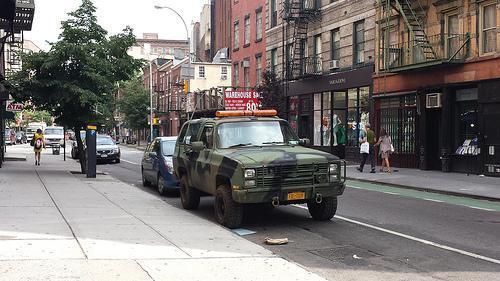How many trucks are there?
Give a very brief answer. 1. 